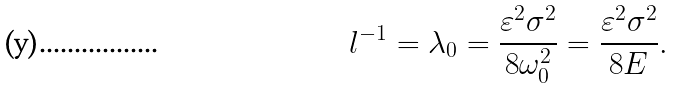<formula> <loc_0><loc_0><loc_500><loc_500>l ^ { - 1 } = \lambda _ { 0 } = \frac { \varepsilon ^ { 2 } \sigma ^ { 2 } } { 8 \omega _ { 0 } ^ { 2 } } = \frac { \varepsilon ^ { 2 } \sigma ^ { 2 } } { 8 E } .</formula> 